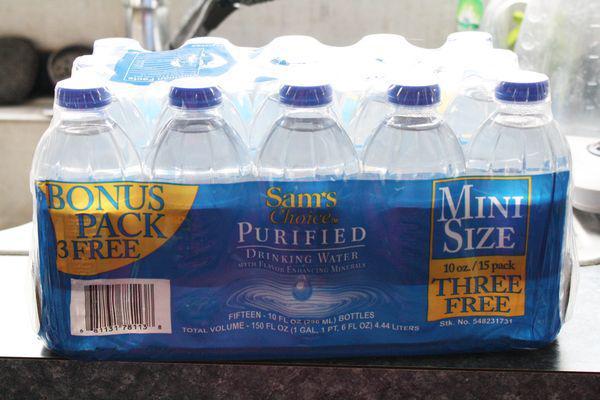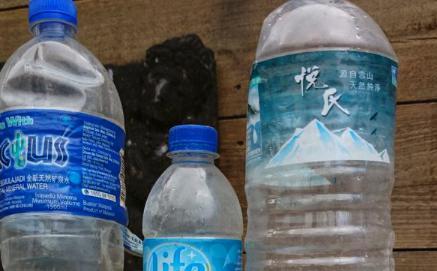The first image is the image on the left, the second image is the image on the right. Examine the images to the left and right. Is the description "At least four bottles in the image on the left side have blue lids." accurate? Answer yes or no. Yes. 